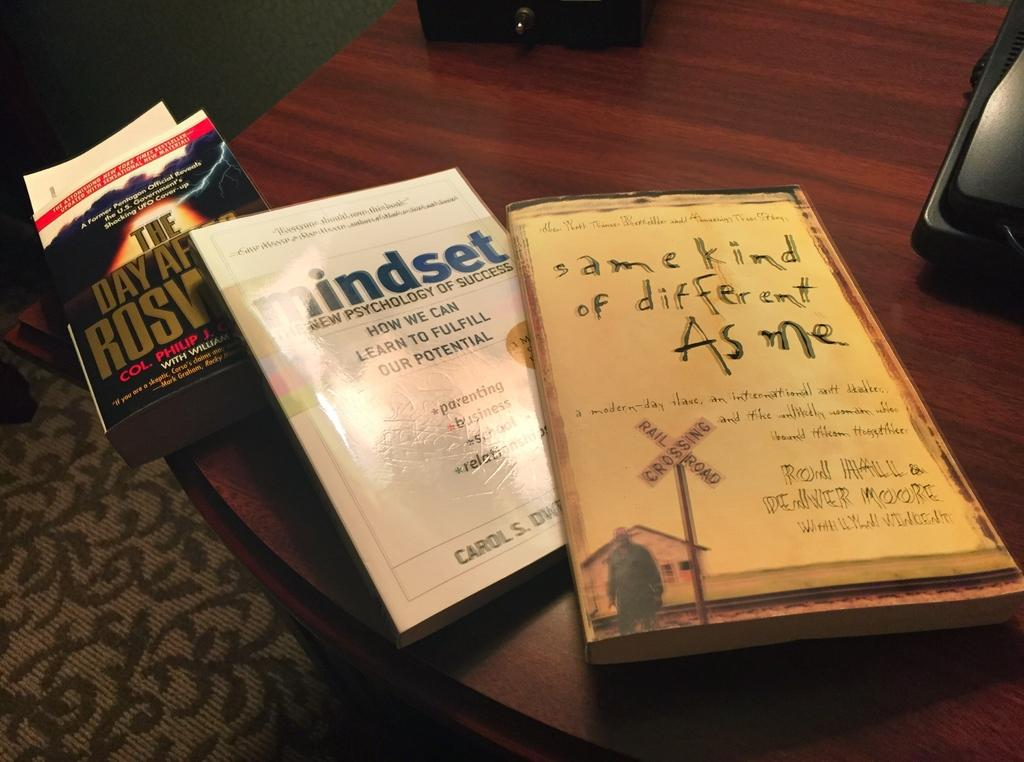<image>
Provide a brief description of the given image. two books, one of which is called Same Kind of Different As Me 